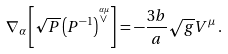Convert formula to latex. <formula><loc_0><loc_0><loc_500><loc_500>\nabla _ { \alpha } \left [ \sqrt { P } \left ( P ^ { - 1 } \right ) ^ { \stackrel { \alpha \mu } { \vee } } \right ] = - \frac { 3 b } { a } \sqrt { g } V ^ { \mu } \, .</formula> 